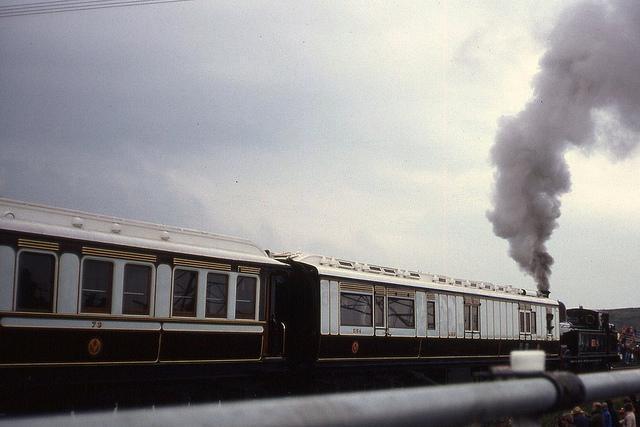How many cards do you see?
Give a very brief answer. 2. 